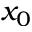Convert formula to latex. <formula><loc_0><loc_0><loc_500><loc_500>x _ { 0 }</formula> 